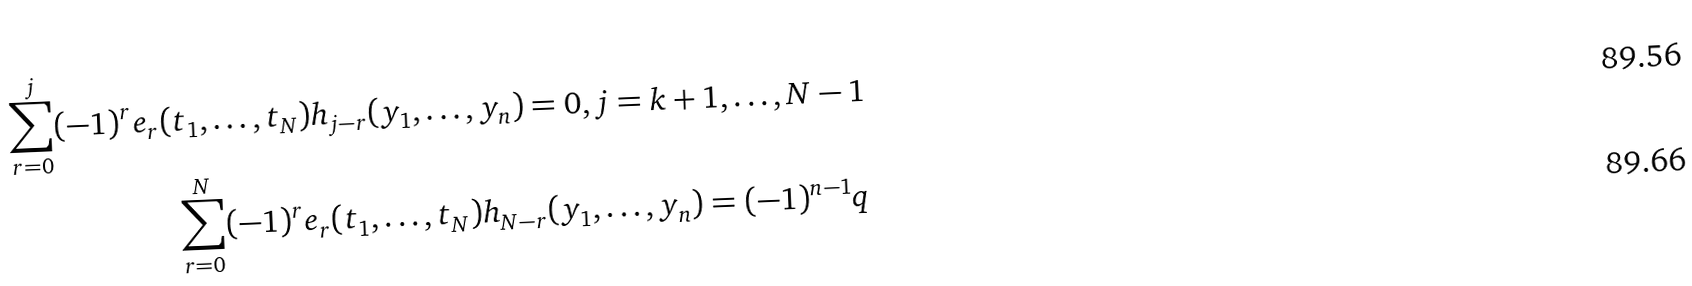<formula> <loc_0><loc_0><loc_500><loc_500>\sum _ { r = 0 } ^ { j } ( - 1 ) ^ { r } e _ { r } ( t _ { 1 } , \dots , t _ { N } ) h _ { j - r } ( y _ { 1 } , \dots , y _ { n } ) = 0 , j = k + 1 , \dots , N - 1 \\ \sum _ { r = 0 } ^ { N } ( - 1 ) ^ { r } e _ { r } ( t _ { 1 } , \dots , t _ { N } ) h _ { N - r } ( y _ { 1 } , \dots , y _ { n } ) = ( - 1 ) ^ { n - 1 } q</formula> 